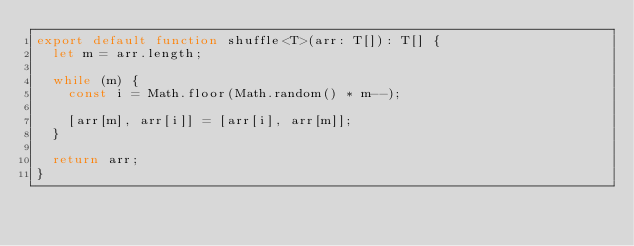Convert code to text. <code><loc_0><loc_0><loc_500><loc_500><_TypeScript_>export default function shuffle<T>(arr: T[]): T[] {
  let m = arr.length;

  while (m) {
    const i = Math.floor(Math.random() * m--);

    [arr[m], arr[i]] = [arr[i], arr[m]];
  }

  return arr;
}
</code> 